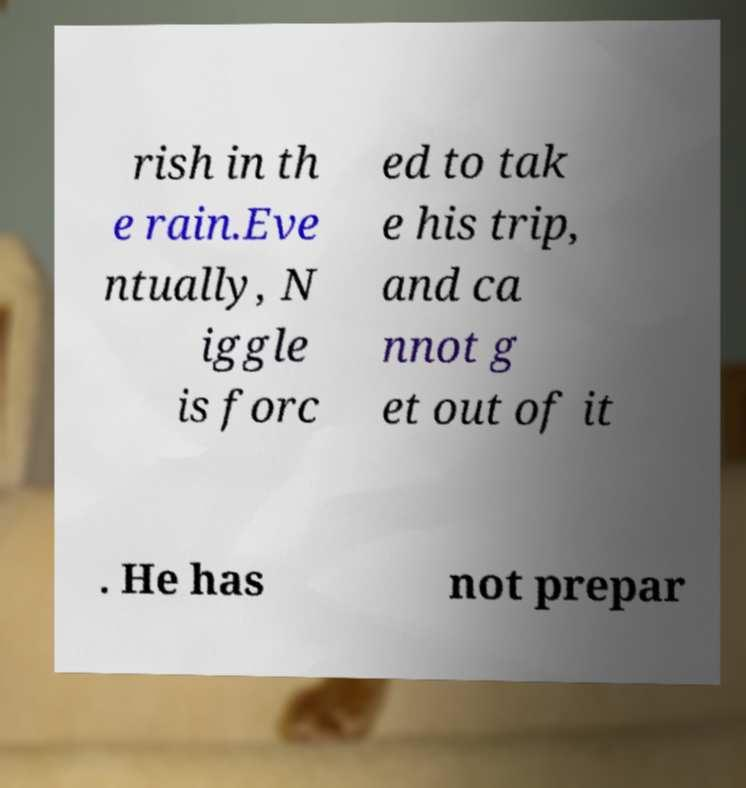What messages or text are displayed in this image? I need them in a readable, typed format. rish in th e rain.Eve ntually, N iggle is forc ed to tak e his trip, and ca nnot g et out of it . He has not prepar 